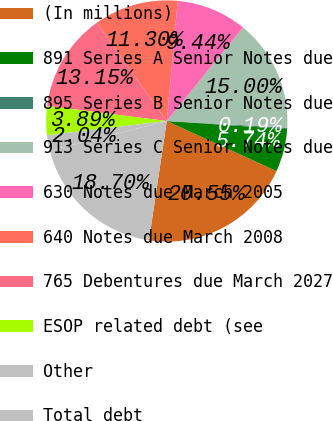Convert chart. <chart><loc_0><loc_0><loc_500><loc_500><pie_chart><fcel>(In millions)<fcel>891 Series A Senior Notes due<fcel>895 Series B Senior Notes due<fcel>913 Series C Senior Notes due<fcel>630 Notes due March 2005<fcel>640 Notes due March 2008<fcel>765 Debentures due March 2027<fcel>ESOP related debt (see<fcel>Other<fcel>Total debt<nl><fcel>20.55%<fcel>5.74%<fcel>0.19%<fcel>15.0%<fcel>9.44%<fcel>11.3%<fcel>13.15%<fcel>3.89%<fcel>2.04%<fcel>18.7%<nl></chart> 